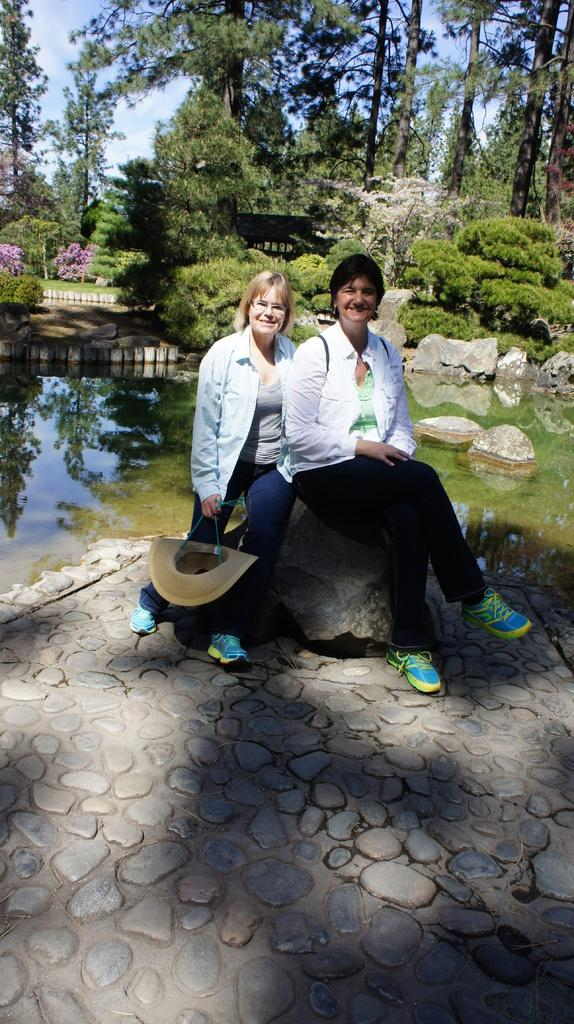How many ladies are in the image? There are two ladies in the image. What are the ladies doing in the image? The ladies are sitting on a rock. What is the lady on the left holding? The lady on the left is holding a hat. What can be seen in the background of the image? There is water, rocks, bushes, trees, and the sky visible in the background. What type of riddle can be solved by the ladies in the image? There is no riddle present in the image, nor is there any indication that the ladies are attempting to solve one. How many chickens are visible in the image? There are no chickens present in the image. 